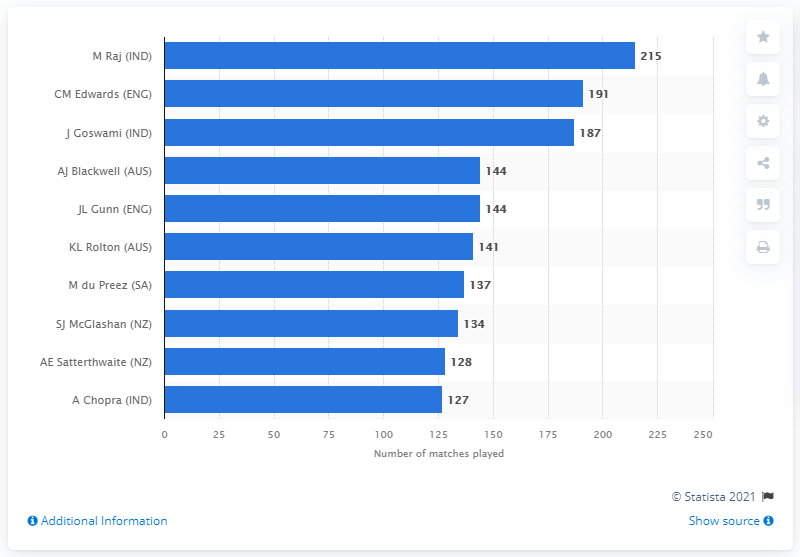Mention a couple of crucial points in this snapshot. Mithali Raj, a renowned Indian cricketer, played a total of 215 Women's ODI matches for India between 1999 and 2021. 